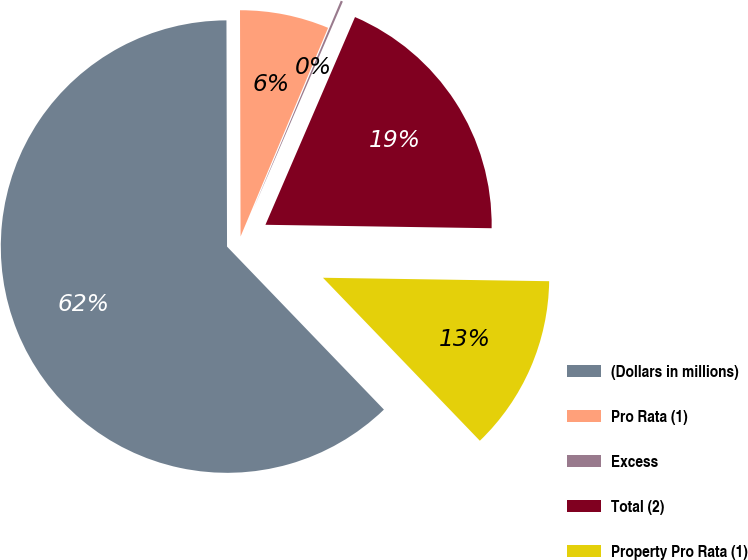Convert chart. <chart><loc_0><loc_0><loc_500><loc_500><pie_chart><fcel>(Dollars in millions)<fcel>Pro Rata (1)<fcel>Excess<fcel>Total (2)<fcel>Property Pro Rata (1)<nl><fcel>62.15%<fcel>6.36%<fcel>0.16%<fcel>18.76%<fcel>12.56%<nl></chart> 